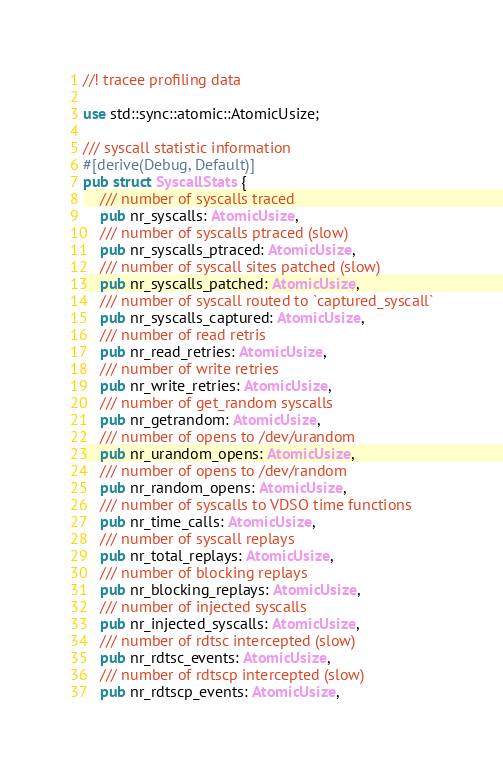<code> <loc_0><loc_0><loc_500><loc_500><_Rust_>//! tracee profiling data

use std::sync::atomic::AtomicUsize;

/// syscall statistic information
#[derive(Debug, Default)]
pub struct SyscallStats {
    /// number of syscalls traced
    pub nr_syscalls: AtomicUsize,
    /// number of syscalls ptraced (slow)
    pub nr_syscalls_ptraced: AtomicUsize,
    /// number of syscall sites patched (slow)
    pub nr_syscalls_patched: AtomicUsize,
    /// number of syscall routed to `captured_syscall`
    pub nr_syscalls_captured: AtomicUsize,
    /// number of read retris
    pub nr_read_retries: AtomicUsize,
    /// number of write retries
    pub nr_write_retries: AtomicUsize,
    /// number of get_random syscalls
    pub nr_getrandom: AtomicUsize,
    /// number of opens to /dev/urandom
    pub nr_urandom_opens: AtomicUsize,
    /// number of opens to /dev/random
    pub nr_random_opens: AtomicUsize,
    /// number of syscalls to VDSO time functions
    pub nr_time_calls: AtomicUsize,
    /// number of syscall replays
    pub nr_total_replays: AtomicUsize,
    /// number of blocking replays
    pub nr_blocking_replays: AtomicUsize,
    /// number of injected syscalls
    pub nr_injected_syscalls: AtomicUsize,
    /// number of rdtsc intercepted (slow)
    pub nr_rdtsc_events: AtomicUsize,
    /// number of rdtscp intercepted (slow)
    pub nr_rdtscp_events: AtomicUsize,</code> 